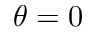Convert formula to latex. <formula><loc_0><loc_0><loc_500><loc_500>\theta = 0</formula> 